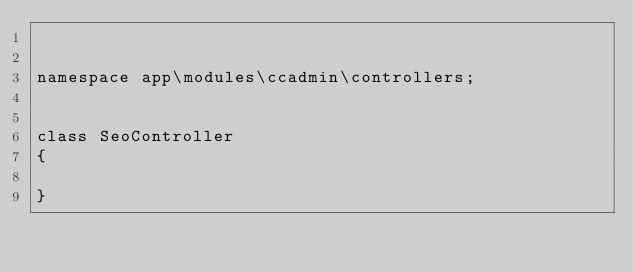Convert code to text. <code><loc_0><loc_0><loc_500><loc_500><_PHP_>

namespace app\modules\ccadmin\controllers;


class SeoController
{

}
</code> 